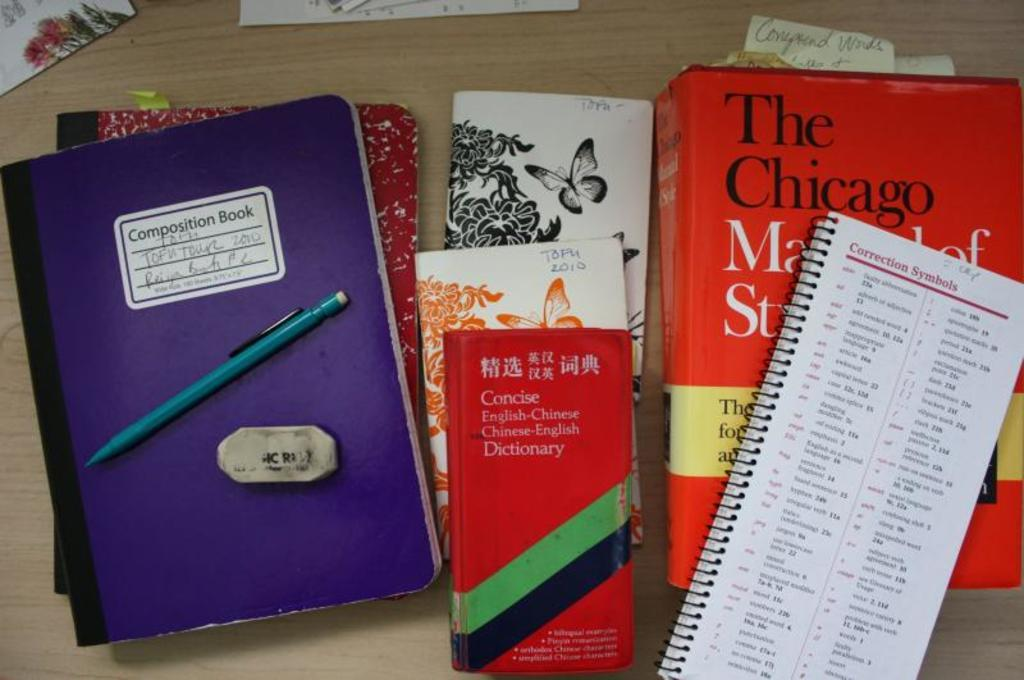<image>
Render a clear and concise summary of the photo. A purple Composition book and a Concise English-Chinese Dictionary. 